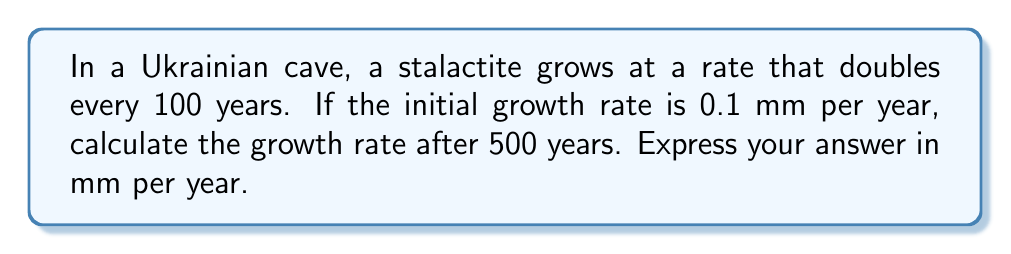Provide a solution to this math problem. Let's approach this step-by-step:

1) We're dealing with exponential growth. The general formula for exponential growth is:

   $$A = A_0 \cdot (1 + r)^t$$

   Where:
   $A$ is the final amount
   $A_0$ is the initial amount
   $r$ is the growth rate
   $t$ is the number of time periods

2) In this case, we know:
   - The growth rate doubles every 100 years
   - The initial growth rate is 0.1 mm per year
   - We want to find the rate after 500 years

3) To find the growth rate $r$, we can use the doubling time formula:

   $$(1 + r)^{100} = 2$$

4) Solving for $r$:

   $$r = 2^{\frac{1}{100}} - 1 \approx 0.007 \text{ or } 0.7\%$$

5) Now we can use the exponential growth formula:

   $$A = 0.1 \cdot (1 + 0.007)^5$$

   Note that we use 5 as the exponent because 500 years = 5 * 100 years

6) Calculating:

   $$A = 0.1 \cdot (1.007)^5 \approx 0.1035$$

Therefore, after 500 years, the growth rate will be approximately 0.1035 mm per year.
Answer: 0.1035 mm/year 